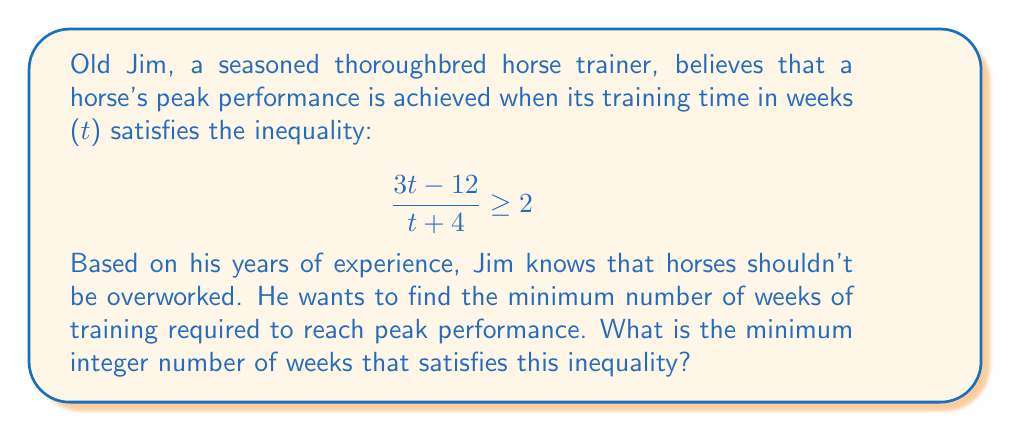Help me with this question. Let's approach this step-by-step:

1) First, we start with the inequality:

   $$ \frac{3t-12}{t+4} \geq 2 $$

2) Multiply both sides by $(t+4)$:

   $$ 3t-12 \geq 2(t+4) $$

3) Expand the right side:

   $$ 3t-12 \geq 2t+8 $$

4) Subtract $2t$ from both sides:

   $$ t-12 \geq 8 $$

5) Add 12 to both sides:

   $$ t \geq 20 $$

6) Therefore, $t$ must be greater than or equal to 20.

7) Since we're looking for the minimum integer number of weeks, and Jim, being old-school, prefers whole numbers, we round up to the nearest integer.

The minimum integer value of $t$ that satisfies the inequality is 20.
Answer: The minimum number of weeks required for training is 20 weeks. 